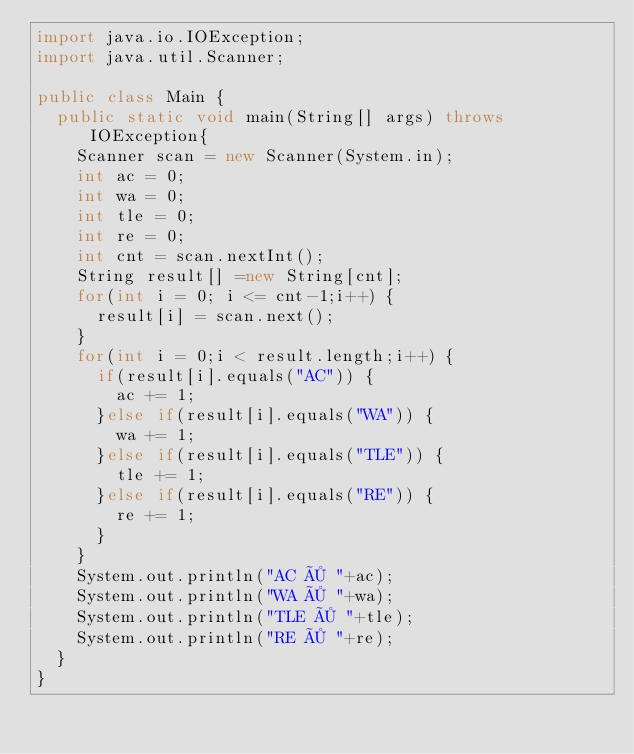Convert code to text. <code><loc_0><loc_0><loc_500><loc_500><_Java_>import java.io.IOException;
import java.util.Scanner;

public class Main {
	public static void main(String[] args) throws IOException{
		Scanner scan = new Scanner(System.in);
		int ac = 0;
		int wa = 0;
		int tle = 0;
		int re = 0;
		int cnt = scan.nextInt();
		String result[] =new String[cnt];
		for(int i = 0; i <= cnt-1;i++) {
			result[i] = scan.next();
		}
		for(int i = 0;i < result.length;i++) {
			if(result[i].equals("AC")) {
				ac += 1;
			}else if(result[i].equals("WA")) {
				wa += 1;
			}else if(result[i].equals("TLE")) {
				tle += 1;
			}else if(result[i].equals("RE")) {
				re += 1;
			}
		}
		System.out.println("AC × "+ac);
		System.out.println("WA × "+wa);
		System.out.println("TLE × "+tle);
		System.out.println("RE × "+re);
	}
}</code> 